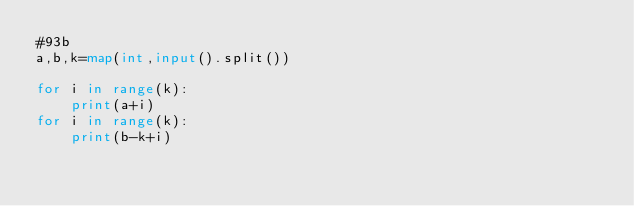<code> <loc_0><loc_0><loc_500><loc_500><_Python_>#93b
a,b,k=map(int,input().split())

for i in range(k):
    print(a+i)
for i in range(k):
    print(b-k+i)
    
    
          </code> 